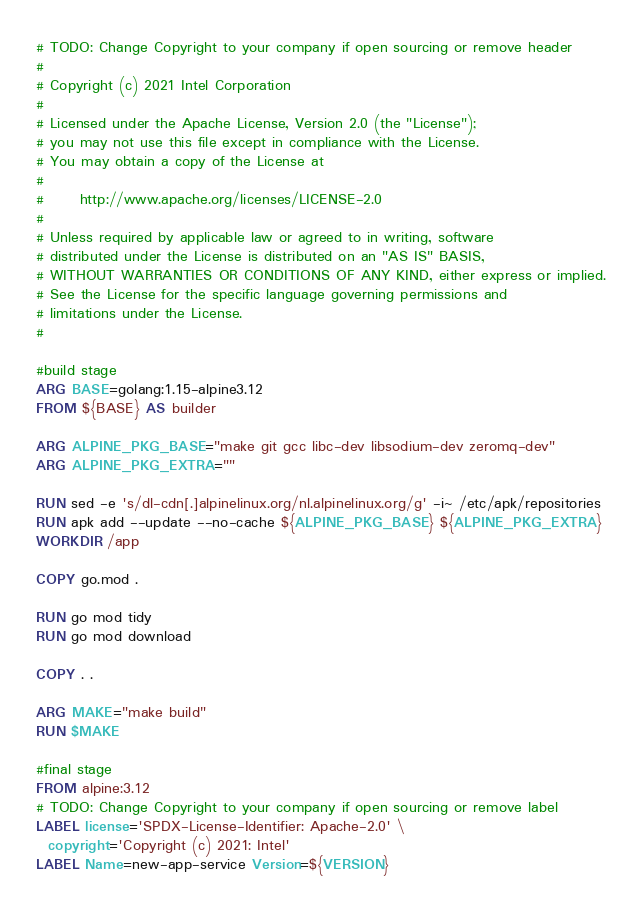Convert code to text. <code><loc_0><loc_0><loc_500><loc_500><_Dockerfile_># TODO: Change Copyright to your company if open sourcing or remove header
#
# Copyright (c) 2021 Intel Corporation
#
# Licensed under the Apache License, Version 2.0 (the "License");
# you may not use this file except in compliance with the License.
# You may obtain a copy of the License at
#
#      http://www.apache.org/licenses/LICENSE-2.0
#
# Unless required by applicable law or agreed to in writing, software
# distributed under the License is distributed on an "AS IS" BASIS,
# WITHOUT WARRANTIES OR CONDITIONS OF ANY KIND, either express or implied.
# See the License for the specific language governing permissions and
# limitations under the License.
#

#build stage
ARG BASE=golang:1.15-alpine3.12
FROM ${BASE} AS builder

ARG ALPINE_PKG_BASE="make git gcc libc-dev libsodium-dev zeromq-dev"
ARG ALPINE_PKG_EXTRA=""

RUN sed -e 's/dl-cdn[.]alpinelinux.org/nl.alpinelinux.org/g' -i~ /etc/apk/repositories
RUN apk add --update --no-cache ${ALPINE_PKG_BASE} ${ALPINE_PKG_EXTRA}
WORKDIR /app

COPY go.mod .

RUN go mod tidy
RUN go mod download

COPY . .

ARG MAKE="make build"
RUN $MAKE

#final stage
FROM alpine:3.12
# TODO: Change Copyright to your company if open sourcing or remove label
LABEL license='SPDX-License-Identifier: Apache-2.0' \
  copyright='Copyright (c) 2021: Intel'
LABEL Name=new-app-service Version=${VERSION}
</code> 